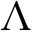<formula> <loc_0><loc_0><loc_500><loc_500>\Lambda</formula> 